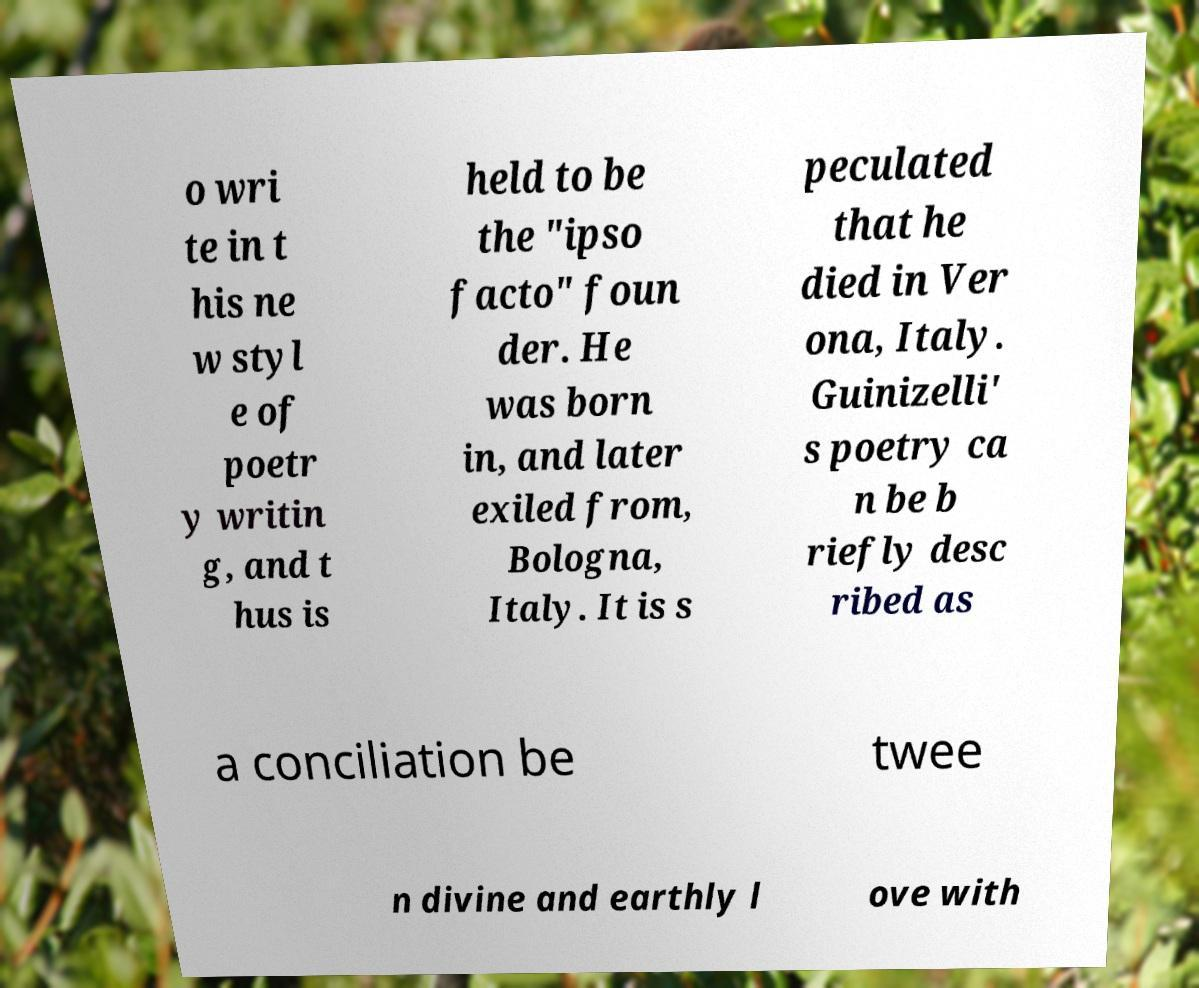Can you accurately transcribe the text from the provided image for me? o wri te in t his ne w styl e of poetr y writin g, and t hus is held to be the "ipso facto" foun der. He was born in, and later exiled from, Bologna, Italy. It is s peculated that he died in Ver ona, Italy. Guinizelli' s poetry ca n be b riefly desc ribed as a conciliation be twee n divine and earthly l ove with 